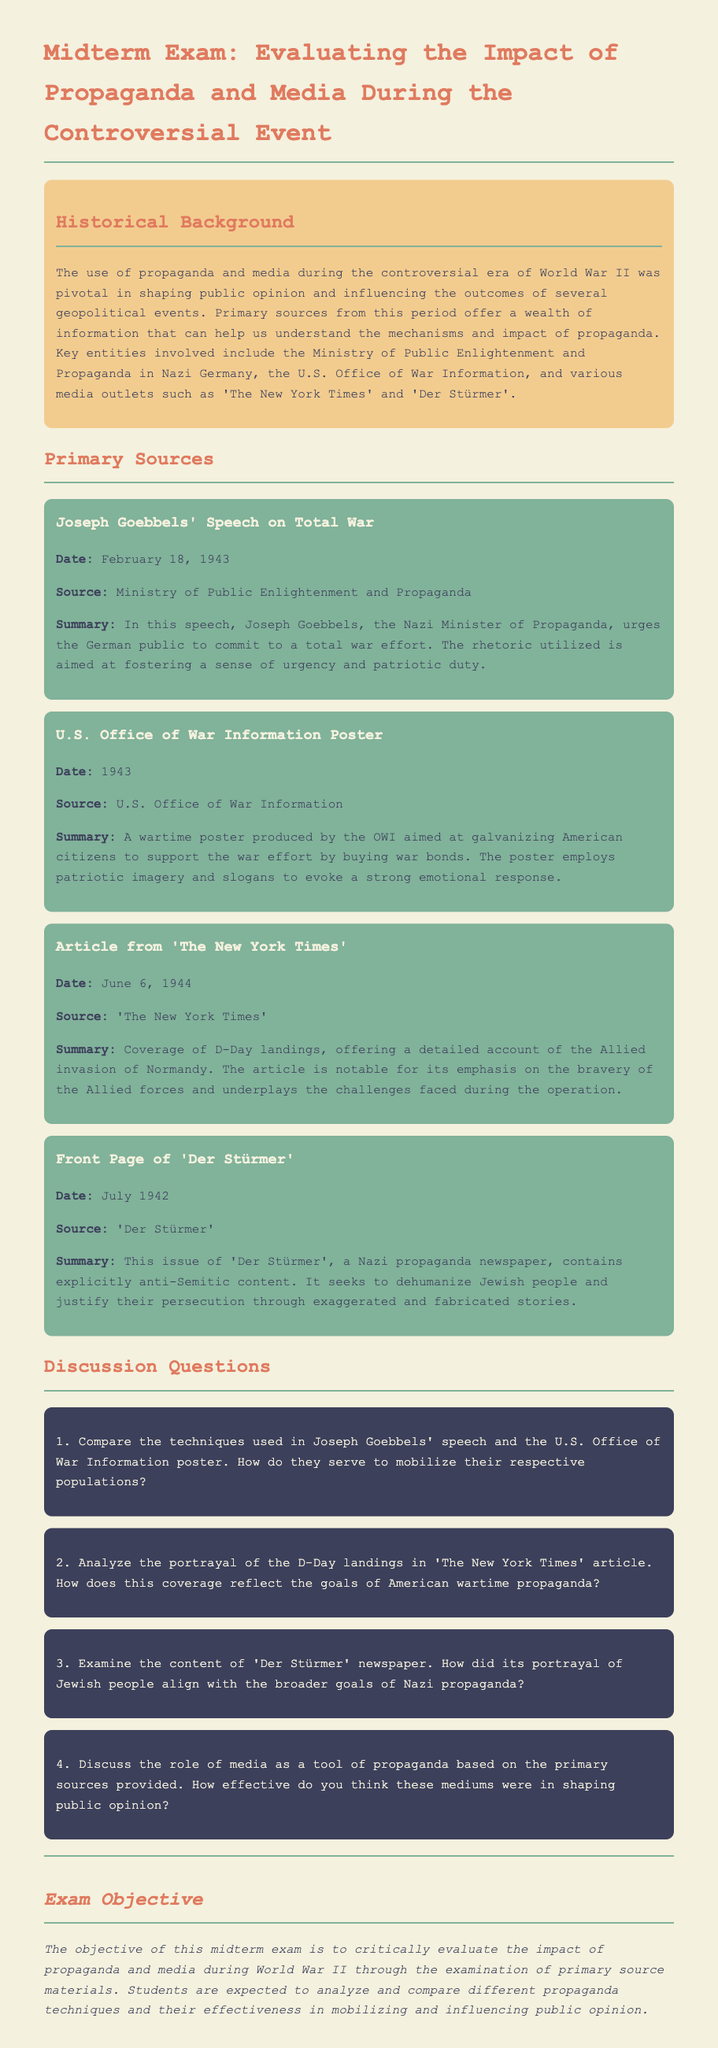What is the date of Joseph Goebbels' speech? The date of Joseph Goebbels' speech, as stated in the document, is February 18, 1943.
Answer: February 18, 1943 What does the OWI poster aim to galvanize American citizens to do? The document states that the OWI poster aims to galvanize American citizens to support the war effort by buying war bonds.
Answer: Buy war bonds Which newspaper published an article on D-Day? The document specifies that 'The New York Times' published an article on D-Day.
Answer: The New York Times What is the publication date of the 'Der Stürmer' front page mentioned? According to the document, the publication date of the 'Der Stürmer' front page is July 1942.
Answer: July 1942 What key entity is associated with the production of Nazi propaganda? The document mentions that the Ministry of Public Enlightenment and Propaganda is a key entity associated with Nazi propaganda.
Answer: Ministry of Public Enlightenment and Propaganda In what way does the 'New York Times' article portray the D-Day landings? The document mentions that the article emphasizes the bravery of the Allied forces and underplays the challenges faced during the operation.
Answer: Emphasizes bravery What type of imagery does the OWI poster employ? The document states that the OWI poster employs patriotic imagery to evoke a strong emotional response.
Answer: Patriotic imagery How did 'Der Stürmer' portray Jewish people? The document notes that 'Der Stürmer' seeks to dehumanize Jewish people through exaggerated and fabricated stories.
Answer: Dehumanize What is the exam objective? The objective of the exam, as stated in the document, is to critically evaluate the impact of propaganda and media during World War II.
Answer: Evaluate the impact of propaganda and media 